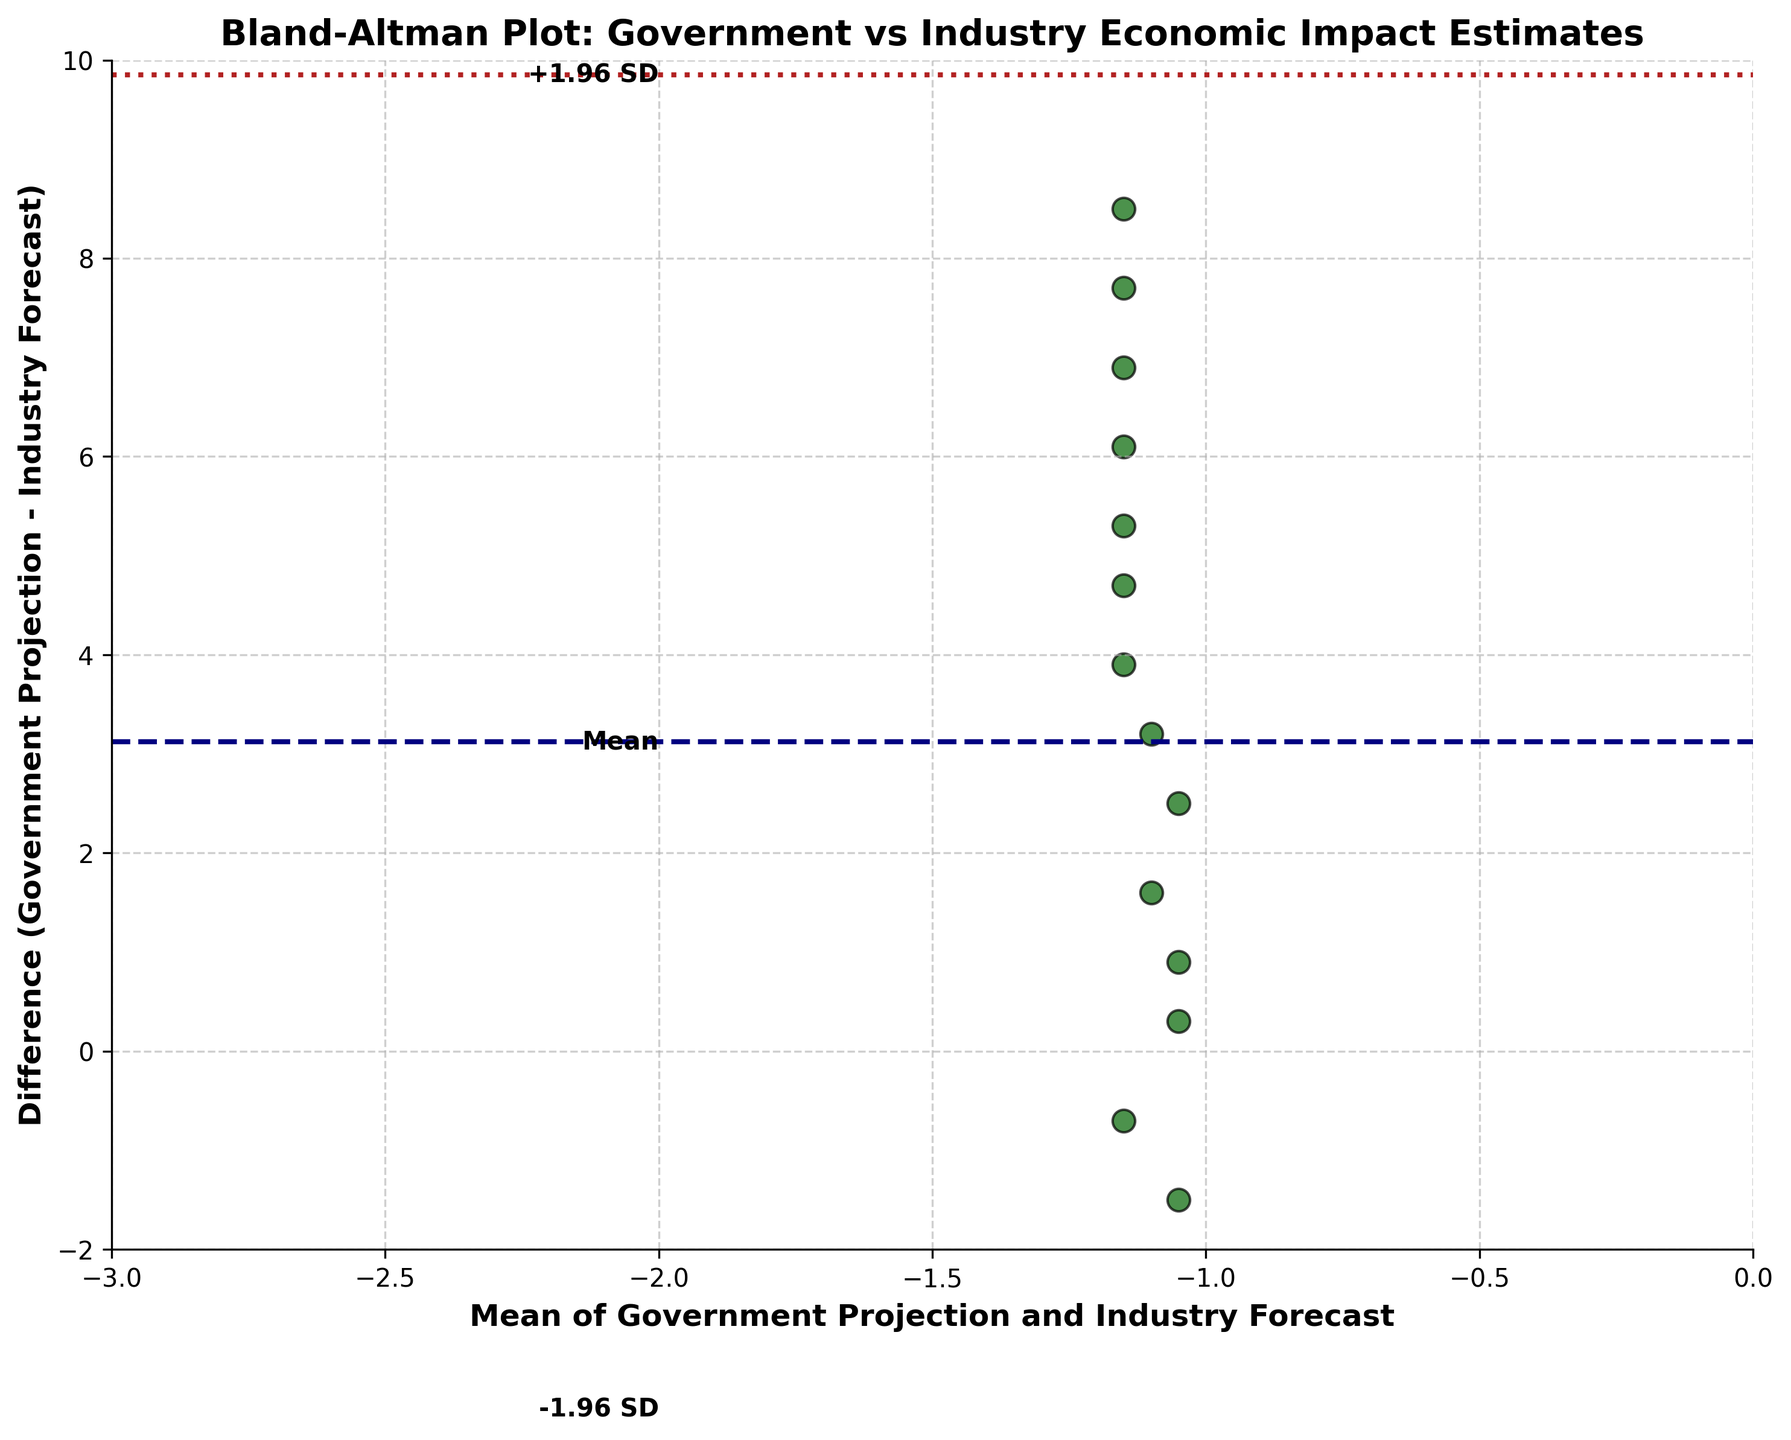What is the title of the plot? The title is located at the top of the figure and indicates what the plot is about.
Answer: Bland-Altman Plot: Government vs Industry Economic Impact Estimates How many data points are plotted? To find the number of data points, you count the individual dots in the scatter plot.
Answer: 15 What does the x-axis represent? The x-axis label indicates what the horizontal axis measures.
Answer: Mean of Government Projection and Industry Forecast What is the mean difference between government projections and industry forecasts? Identify the middle reference line on the y-axis labeled 'Mean' and see where it intersects with the y-axis.
Answer: -2.8 What is the meaning of the dashed and dotted lines on the plot? The dashed line represents the mean difference, while the dotted lines depict the limits of agreement (mean difference ± 1.96*SD).
Answer: Mean difference and limits of agreement What is the value of the upper limit of agreement? Identify the upper dotted line on the y-axis labeled '+1.96 SD' and see where it intersects with the y-axis.
Answer: -0.06 Is there a trend in the differences as the mean increases? Examine whether the differences (vertical distances of the points) show any pattern relative to the mean (horizontal position).
Answer: Yes, differences appear to become more negative as the mean increases Are the majority of differences within the limits of agreement? Compare the spread of data points to see if they mostly lie within the upper and lower limits defined by the dotted lines.
Answer: Yes What does a point at the mean value of -0.3 indicate about the difference between government projection and industry forecast? Locate the points with a mean value around -0.3 on the x-axis and see their corresponding value on the y-axis (difference).
Answer: Government projection is higher by approximately +1.6 Are there data points outside the limits of agreement? Examine if any points fall above or below the dotted lines representing the limits of agreement.
Answer: No 